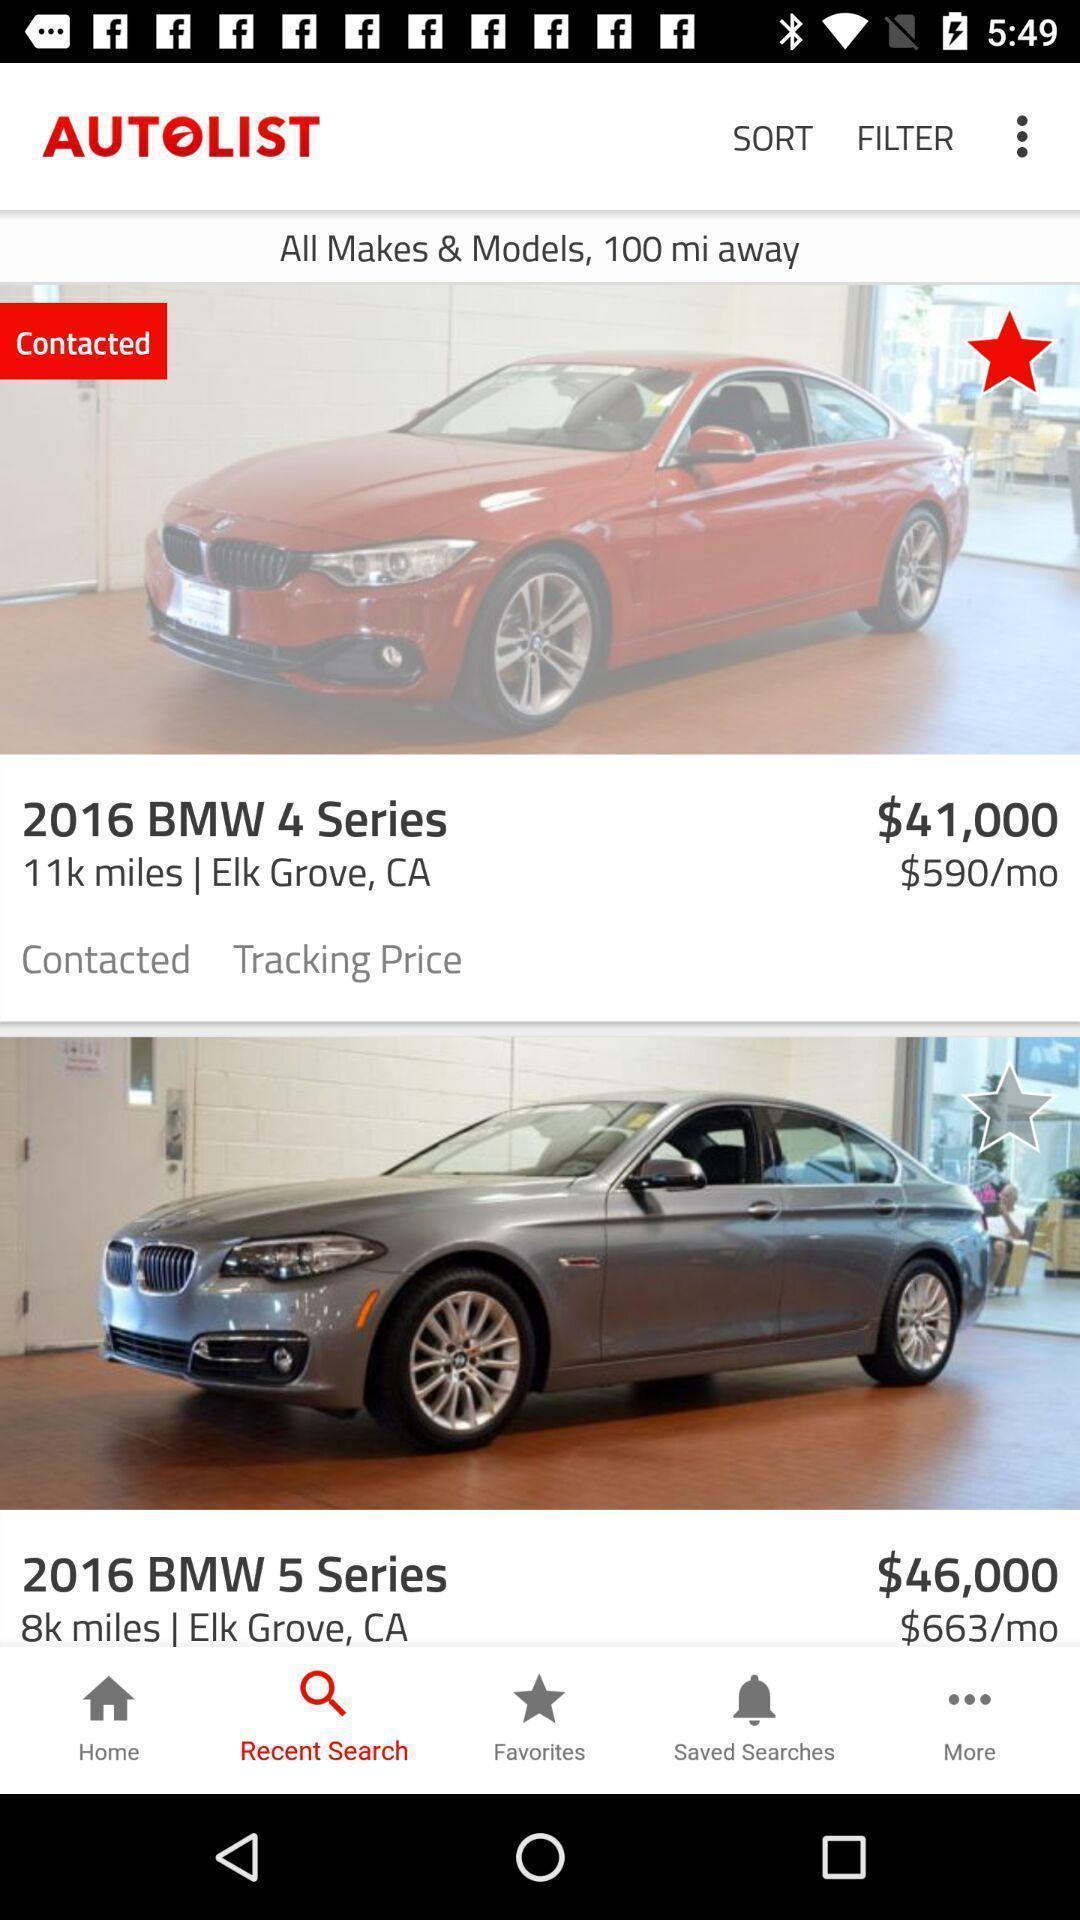What is the overall content of this screenshot? Search result showing car prices in a shopping app. 